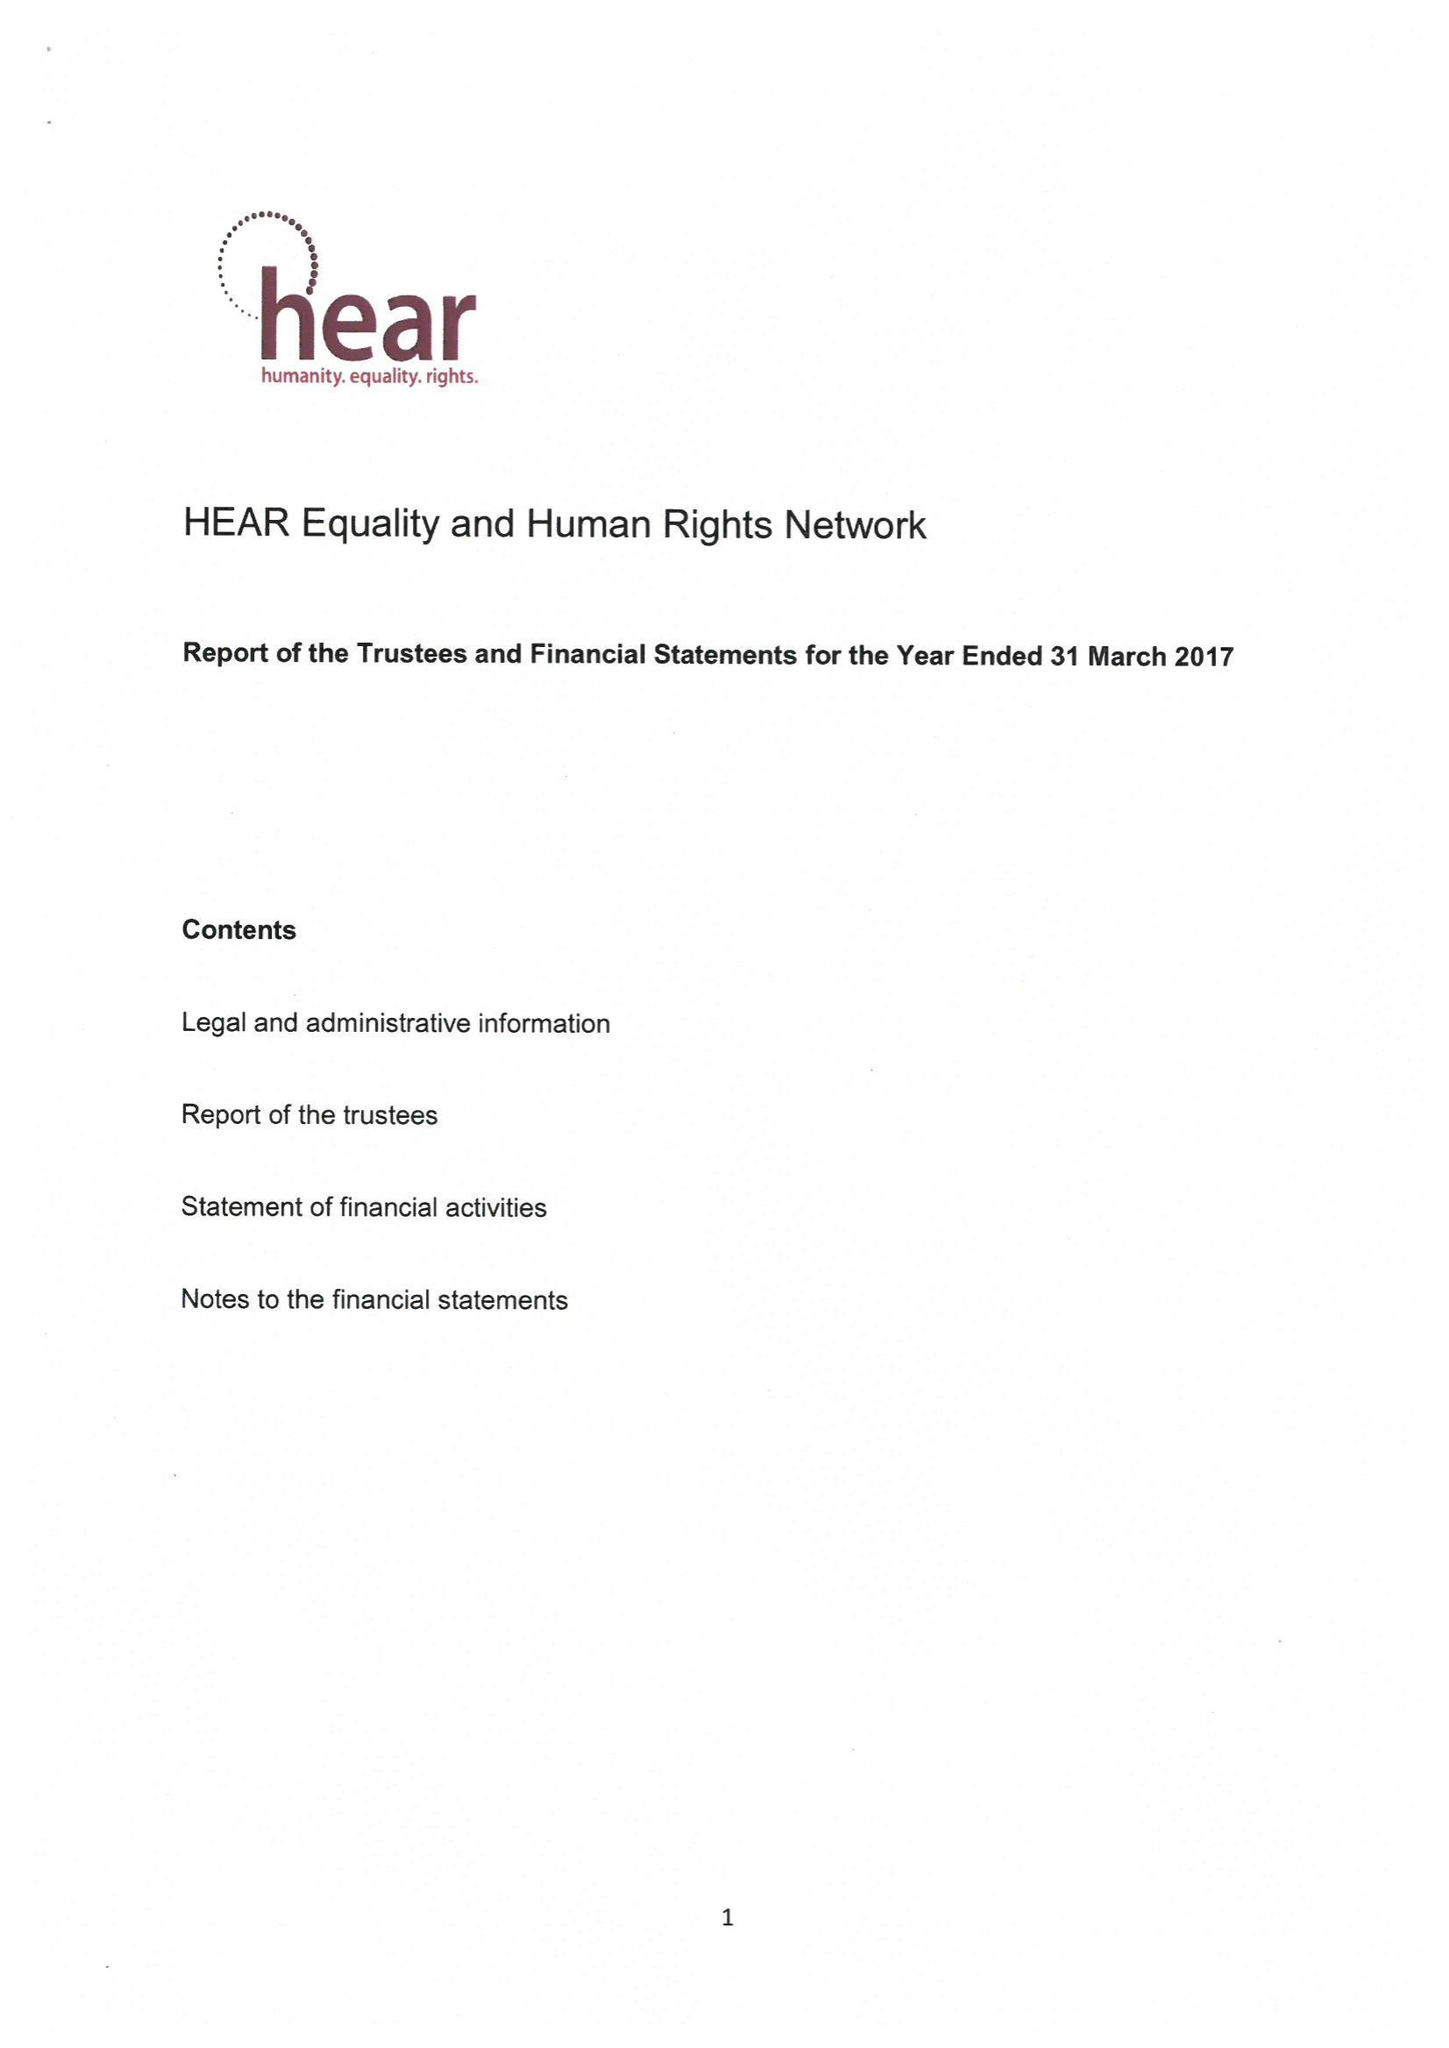What is the value for the address__postcode?
Answer the question using a single word or phrase. N1 9JP 